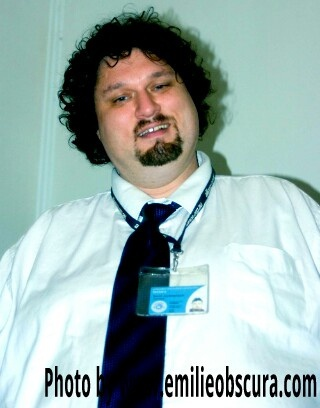Describe the objects in this image and their specific colors. I can see people in white, lightblue, black, and tan tones and tie in lightblue, black, teal, and navy tones in this image. 